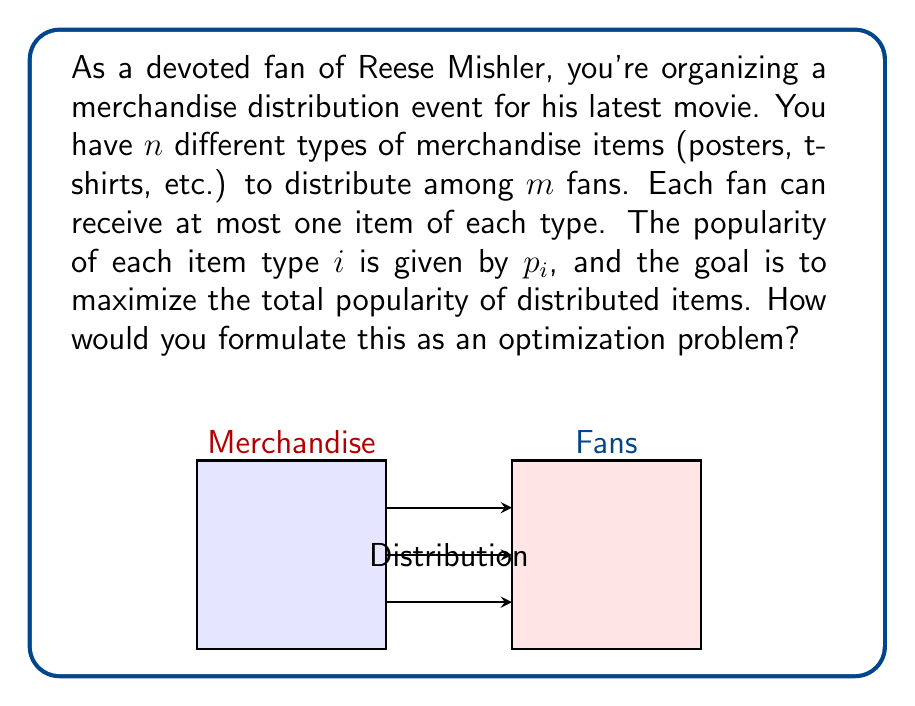Help me with this question. To formulate this as an optimization problem, we need to:

1. Define decision variables:
   Let $x_{ij}$ be a binary variable where:
   $$x_{ij} = \begin{cases}
   1 & \text{if item type } i \text{ is given to fan } j \\
   0 & \text{otherwise}
   \end{cases}$$

2. Objective function:
   We want to maximize the total popularity of distributed items:
   $$\text{Maximize } \sum_{i=1}^n \sum_{j=1}^m p_i x_{ij}$$

3. Constraints:
   a) Each fan can receive at most one item of each type:
      $$\sum_{j=1}^m x_{ij} \leq 1 \quad \forall i = 1,\ldots,n$$
   
   b) Each item can be given to at most one fan:
      $$\sum_{i=1}^n x_{ij} \leq 1 \quad \forall j = 1,\ldots,m$$
   
   c) Binary constraint:
      $$x_{ij} \in \{0,1\} \quad \forall i = 1,\ldots,n, \quad \forall j = 1,\ldots,m$$

This formulation creates an Integer Linear Programming (ILP) problem, which can be solved using various optimization techniques such as branch-and-bound or cutting-plane methods.
Answer: Maximize $\sum_{i=1}^n \sum_{j=1}^m p_i x_{ij}$ subject to $\sum_{j=1}^m x_{ij} \leq 1$, $\sum_{i=1}^n x_{ij} \leq 1$, $x_{ij} \in \{0,1\}$ 